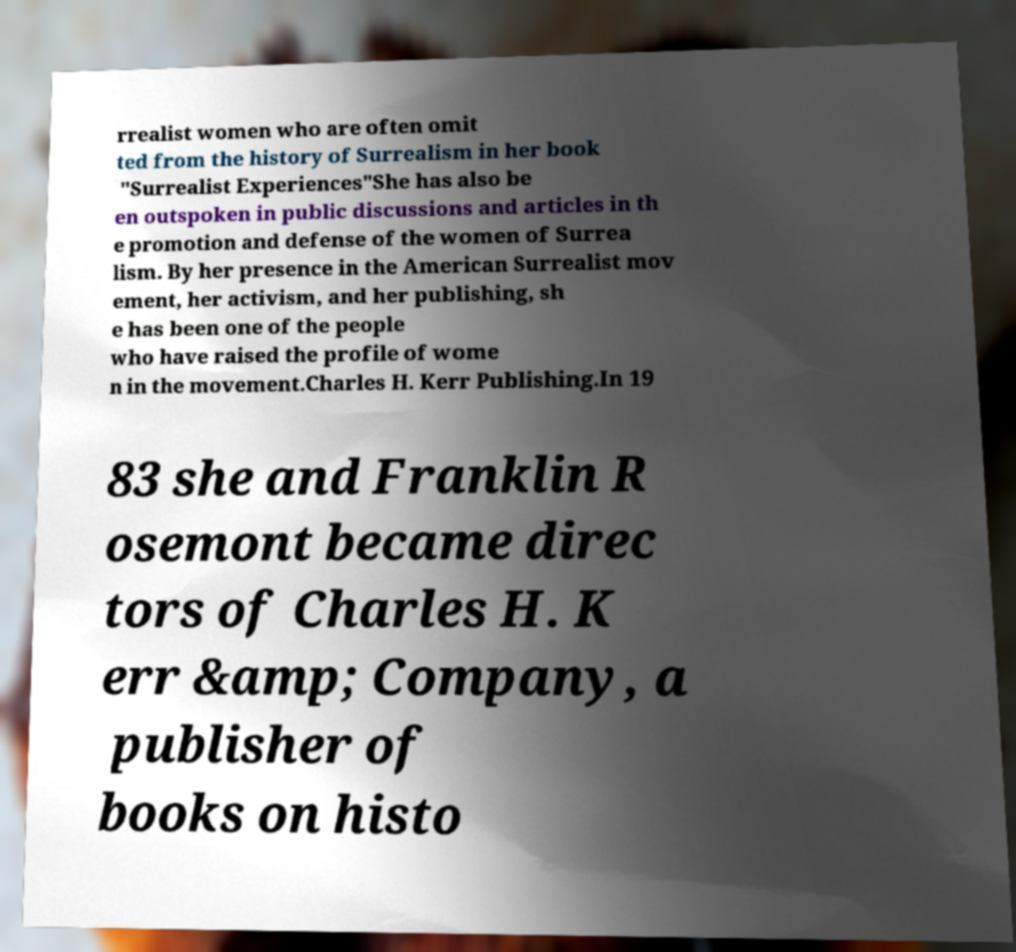There's text embedded in this image that I need extracted. Can you transcribe it verbatim? rrealist women who are often omit ted from the history of Surrealism in her book "Surrealist Experiences"She has also be en outspoken in public discussions and articles in th e promotion and defense of the women of Surrea lism. By her presence in the American Surrealist mov ement, her activism, and her publishing, sh e has been one of the people who have raised the profile of wome n in the movement.Charles H. Kerr Publishing.In 19 83 she and Franklin R osemont became direc tors of Charles H. K err &amp; Company, a publisher of books on histo 